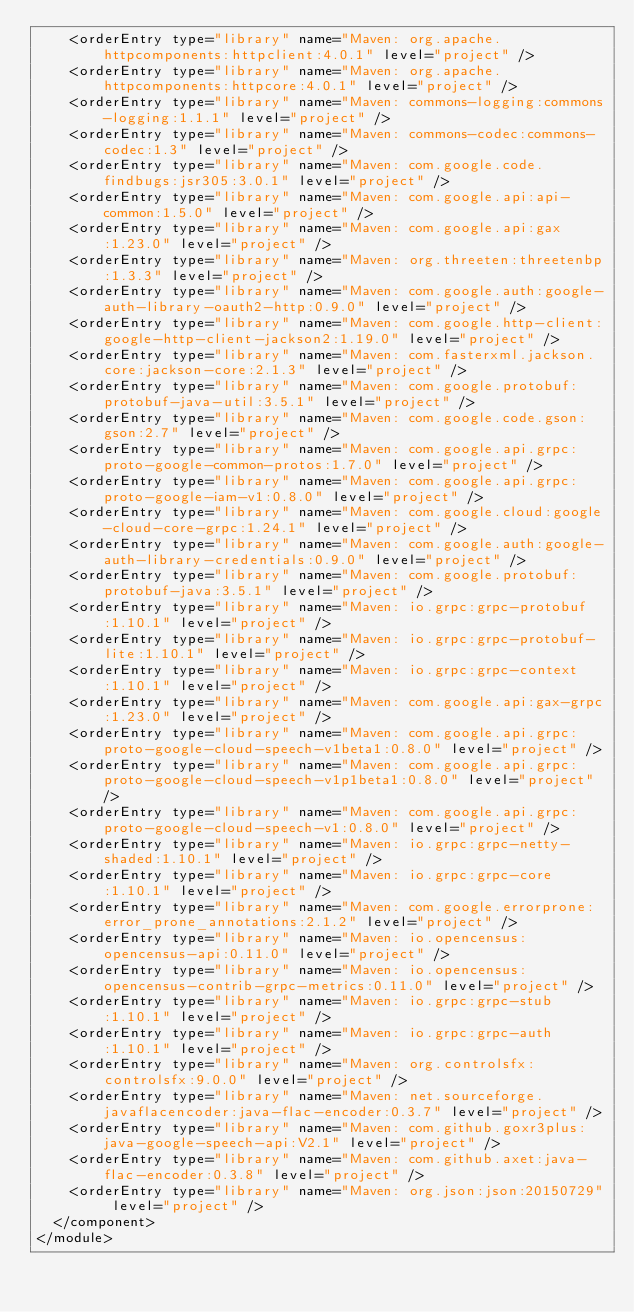<code> <loc_0><loc_0><loc_500><loc_500><_XML_>    <orderEntry type="library" name="Maven: org.apache.httpcomponents:httpclient:4.0.1" level="project" />
    <orderEntry type="library" name="Maven: org.apache.httpcomponents:httpcore:4.0.1" level="project" />
    <orderEntry type="library" name="Maven: commons-logging:commons-logging:1.1.1" level="project" />
    <orderEntry type="library" name="Maven: commons-codec:commons-codec:1.3" level="project" />
    <orderEntry type="library" name="Maven: com.google.code.findbugs:jsr305:3.0.1" level="project" />
    <orderEntry type="library" name="Maven: com.google.api:api-common:1.5.0" level="project" />
    <orderEntry type="library" name="Maven: com.google.api:gax:1.23.0" level="project" />
    <orderEntry type="library" name="Maven: org.threeten:threetenbp:1.3.3" level="project" />
    <orderEntry type="library" name="Maven: com.google.auth:google-auth-library-oauth2-http:0.9.0" level="project" />
    <orderEntry type="library" name="Maven: com.google.http-client:google-http-client-jackson2:1.19.0" level="project" />
    <orderEntry type="library" name="Maven: com.fasterxml.jackson.core:jackson-core:2.1.3" level="project" />
    <orderEntry type="library" name="Maven: com.google.protobuf:protobuf-java-util:3.5.1" level="project" />
    <orderEntry type="library" name="Maven: com.google.code.gson:gson:2.7" level="project" />
    <orderEntry type="library" name="Maven: com.google.api.grpc:proto-google-common-protos:1.7.0" level="project" />
    <orderEntry type="library" name="Maven: com.google.api.grpc:proto-google-iam-v1:0.8.0" level="project" />
    <orderEntry type="library" name="Maven: com.google.cloud:google-cloud-core-grpc:1.24.1" level="project" />
    <orderEntry type="library" name="Maven: com.google.auth:google-auth-library-credentials:0.9.0" level="project" />
    <orderEntry type="library" name="Maven: com.google.protobuf:protobuf-java:3.5.1" level="project" />
    <orderEntry type="library" name="Maven: io.grpc:grpc-protobuf:1.10.1" level="project" />
    <orderEntry type="library" name="Maven: io.grpc:grpc-protobuf-lite:1.10.1" level="project" />
    <orderEntry type="library" name="Maven: io.grpc:grpc-context:1.10.1" level="project" />
    <orderEntry type="library" name="Maven: com.google.api:gax-grpc:1.23.0" level="project" />
    <orderEntry type="library" name="Maven: com.google.api.grpc:proto-google-cloud-speech-v1beta1:0.8.0" level="project" />
    <orderEntry type="library" name="Maven: com.google.api.grpc:proto-google-cloud-speech-v1p1beta1:0.8.0" level="project" />
    <orderEntry type="library" name="Maven: com.google.api.grpc:proto-google-cloud-speech-v1:0.8.0" level="project" />
    <orderEntry type="library" name="Maven: io.grpc:grpc-netty-shaded:1.10.1" level="project" />
    <orderEntry type="library" name="Maven: io.grpc:grpc-core:1.10.1" level="project" />
    <orderEntry type="library" name="Maven: com.google.errorprone:error_prone_annotations:2.1.2" level="project" />
    <orderEntry type="library" name="Maven: io.opencensus:opencensus-api:0.11.0" level="project" />
    <orderEntry type="library" name="Maven: io.opencensus:opencensus-contrib-grpc-metrics:0.11.0" level="project" />
    <orderEntry type="library" name="Maven: io.grpc:grpc-stub:1.10.1" level="project" />
    <orderEntry type="library" name="Maven: io.grpc:grpc-auth:1.10.1" level="project" />
    <orderEntry type="library" name="Maven: org.controlsfx:controlsfx:9.0.0" level="project" />
    <orderEntry type="library" name="Maven: net.sourceforge.javaflacencoder:java-flac-encoder:0.3.7" level="project" />
    <orderEntry type="library" name="Maven: com.github.goxr3plus:java-google-speech-api:V2.1" level="project" />
    <orderEntry type="library" name="Maven: com.github.axet:java-flac-encoder:0.3.8" level="project" />
    <orderEntry type="library" name="Maven: org.json:json:20150729" level="project" />
  </component>
</module></code> 